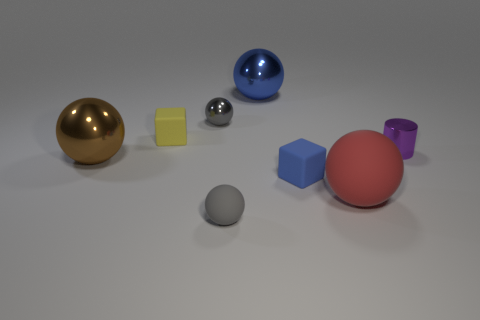What number of big things are gray metal blocks or gray rubber objects?
Your answer should be very brief. 0. There is a big blue object that is the same shape as the large brown metal thing; what material is it?
Offer a very short reply. Metal. The tiny metal cylinder has what color?
Keep it short and to the point. Purple. Do the tiny metal ball and the small rubber sphere have the same color?
Offer a very short reply. Yes. What number of matte spheres are behind the tiny gray ball behind the small gray matte object?
Make the answer very short. 0. There is a ball that is both behind the purple metal thing and left of the tiny rubber ball; what is its size?
Provide a succinct answer. Small. What is the material of the tiny ball behind the small blue object?
Ensure brevity in your answer.  Metal. Is there another thing of the same shape as the red rubber thing?
Make the answer very short. Yes. How many red matte objects have the same shape as the blue shiny thing?
Offer a very short reply. 1. Do the gray object that is in front of the tiny gray metallic object and the brown shiny thing to the left of the big matte thing have the same size?
Ensure brevity in your answer.  No. 